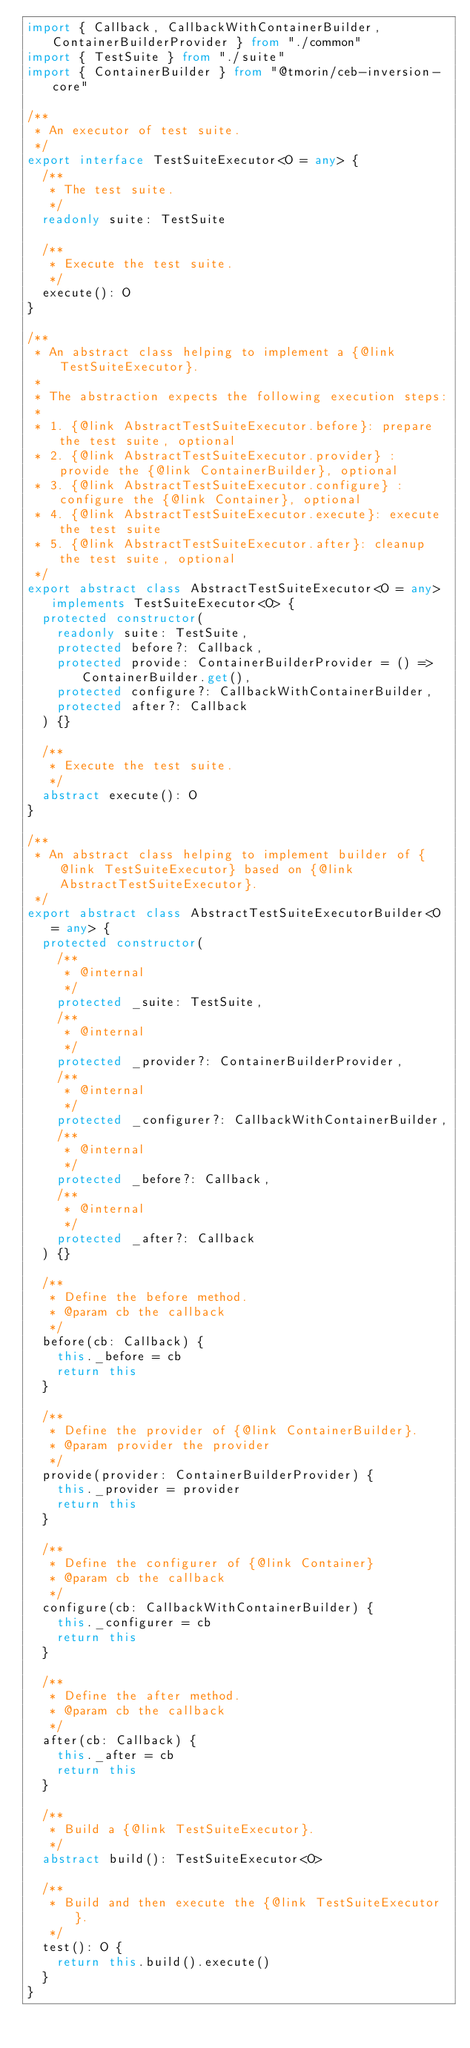<code> <loc_0><loc_0><loc_500><loc_500><_TypeScript_>import { Callback, CallbackWithContainerBuilder, ContainerBuilderProvider } from "./common"
import { TestSuite } from "./suite"
import { ContainerBuilder } from "@tmorin/ceb-inversion-core"

/**
 * An executor of test suite.
 */
export interface TestSuiteExecutor<O = any> {
  /**
   * The test suite.
   */
  readonly suite: TestSuite

  /**
   * Execute the test suite.
   */
  execute(): O
}

/**
 * An abstract class helping to implement a {@link TestSuiteExecutor}.
 *
 * The abstraction expects the following execution steps:
 *
 * 1. {@link AbstractTestSuiteExecutor.before}: prepare the test suite, optional
 * 2. {@link AbstractTestSuiteExecutor.provider} : provide the {@link ContainerBuilder}, optional
 * 3. {@link AbstractTestSuiteExecutor.configure} : configure the {@link Container}, optional
 * 4. {@link AbstractTestSuiteExecutor.execute}: execute the test suite
 * 5. {@link AbstractTestSuiteExecutor.after}: cleanup the test suite, optional
 */
export abstract class AbstractTestSuiteExecutor<O = any> implements TestSuiteExecutor<O> {
  protected constructor(
    readonly suite: TestSuite,
    protected before?: Callback,
    protected provide: ContainerBuilderProvider = () => ContainerBuilder.get(),
    protected configure?: CallbackWithContainerBuilder,
    protected after?: Callback
  ) {}

  /**
   * Execute the test suite.
   */
  abstract execute(): O
}

/**
 * An abstract class helping to implement builder of {@link TestSuiteExecutor} based on {@link AbstractTestSuiteExecutor}.
 */
export abstract class AbstractTestSuiteExecutorBuilder<O = any> {
  protected constructor(
    /**
     * @internal
     */
    protected _suite: TestSuite,
    /**
     * @internal
     */
    protected _provider?: ContainerBuilderProvider,
    /**
     * @internal
     */
    protected _configurer?: CallbackWithContainerBuilder,
    /**
     * @internal
     */
    protected _before?: Callback,
    /**
     * @internal
     */
    protected _after?: Callback
  ) {}

  /**
   * Define the before method.
   * @param cb the callback
   */
  before(cb: Callback) {
    this._before = cb
    return this
  }

  /**
   * Define the provider of {@link ContainerBuilder}.
   * @param provider the provider
   */
  provide(provider: ContainerBuilderProvider) {
    this._provider = provider
    return this
  }

  /**
   * Define the configurer of {@link Container}
   * @param cb the callback
   */
  configure(cb: CallbackWithContainerBuilder) {
    this._configurer = cb
    return this
  }

  /**
   * Define the after method.
   * @param cb the callback
   */
  after(cb: Callback) {
    this._after = cb
    return this
  }

  /**
   * Build a {@link TestSuiteExecutor}.
   */
  abstract build(): TestSuiteExecutor<O>

  /**
   * Build and then execute the {@link TestSuiteExecutor}.
   */
  test(): O {
    return this.build().execute()
  }
}
</code> 